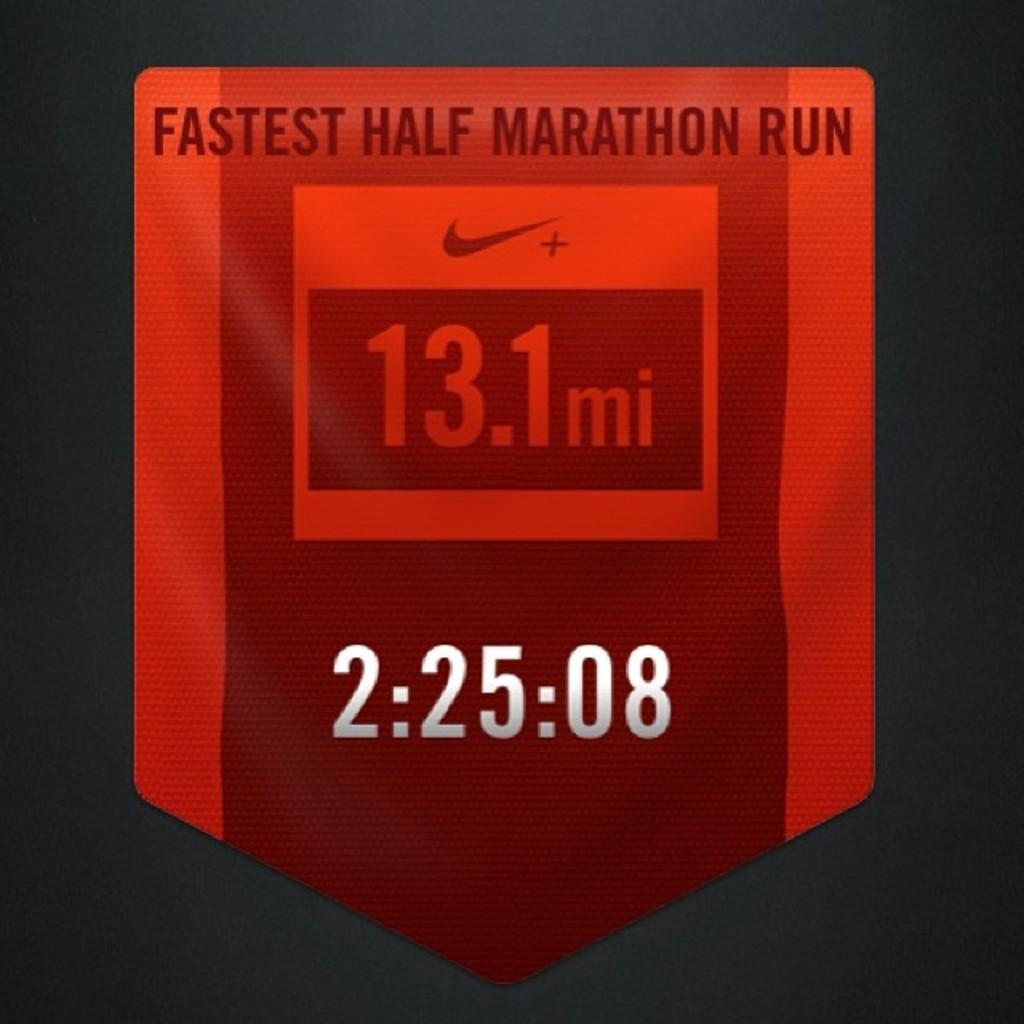<image>
Summarize the visual content of the image. A sign showing the time of the fastest half marathon run 